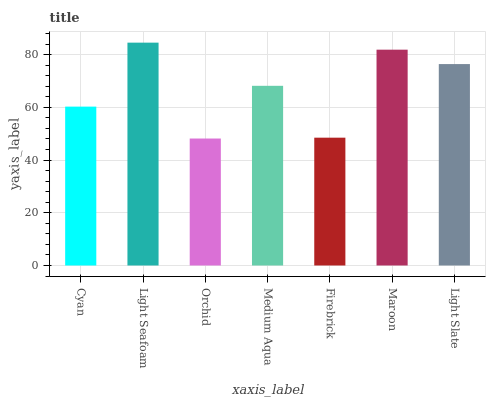Is Light Seafoam the minimum?
Answer yes or no. No. Is Orchid the maximum?
Answer yes or no. No. Is Light Seafoam greater than Orchid?
Answer yes or no. Yes. Is Orchid less than Light Seafoam?
Answer yes or no. Yes. Is Orchid greater than Light Seafoam?
Answer yes or no. No. Is Light Seafoam less than Orchid?
Answer yes or no. No. Is Medium Aqua the high median?
Answer yes or no. Yes. Is Medium Aqua the low median?
Answer yes or no. Yes. Is Light Slate the high median?
Answer yes or no. No. Is Light Seafoam the low median?
Answer yes or no. No. 